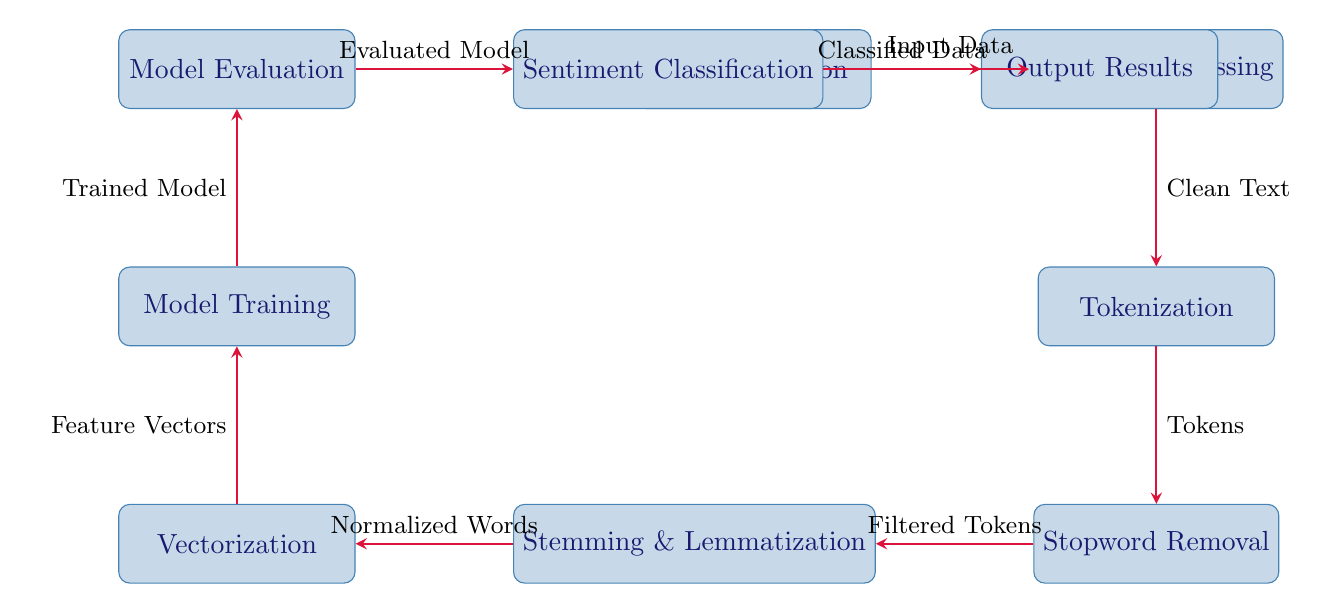What are the first two processes in the diagram? The diagram starts with "Data Collection" and the second process is "Data Preprocessing." This can be observed directly from the leftmost node flowing to the adjacent right node.
Answer: Data Collection, Data Preprocessing How many processes are shown in the diagram? Counting all the rectangular nodes in the diagram, there are eight distinct processes: Data Collection, Data Preprocessing, Tokenization, Stopword Removal, Stemming & Lemmatization, Vectorization, Model Training, Model Evaluation, Sentiment Classification, and Output Results. Adding these gives a total of eight processes.
Answer: Eight What is the output of the "Sentiment Classification" process? The output of "Sentiment Classification" is "Classified Data," which is indicated as the output node directly to the right of "Sentiment Classification."
Answer: Classified Data Which process immediately follows "Model Evaluation"? The process that follows "Model Evaluation" directly is "Sentiment Classification," as indicated by the arrow that connects these two nodes in the diagram.
Answer: Sentiment Classification What is the input to the "Data Preprocessing"? The input to "Data Preprocessing" is "Input Data," which is clearly labeled as flowing from "Data Collection" to "Data Preprocessing" via the arrow above it.
Answer: Input Data How do "Tokenization" and "Stopword Removal" relate in the workflow? "Tokenization" leads to "Stopword Removal," as per the directional arrow connecting the two processes from above. This indicates that the output of "Tokenization" becomes the input for "Stopword Removal."
Answer: Tokenization leads to Stopword Removal What step occurs after "Vectorization"? The step that occurs after "Vectorization" is "Model Training," which is indicated by the connection arrow flowing directly upwards from "Vectorization."
Answer: Model Training What type of processing happens after "Data Preprocessing"? After "Data Preprocessing," the type of processing that occurs is named "Tokenization," which directly follows in the workflow sequence based on the layout of the diagram.
Answer: Tokenization 